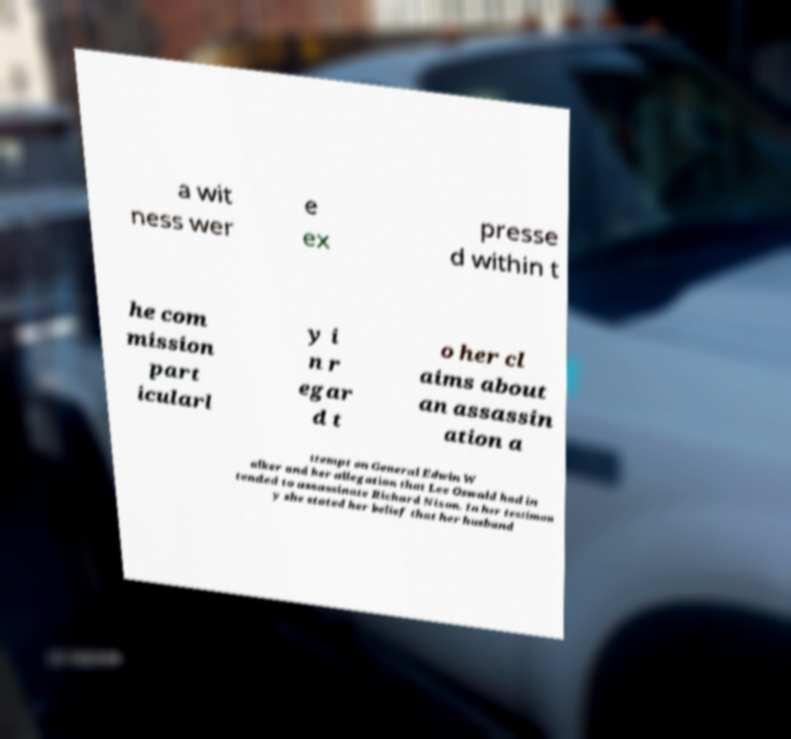Could you assist in decoding the text presented in this image and type it out clearly? a wit ness wer e ex presse d within t he com mission part icularl y i n r egar d t o her cl aims about an assassin ation a ttempt on General Edwin W alker and her allegation that Lee Oswald had in tended to assassinate Richard Nixon. In her testimon y she stated her belief that her husband 